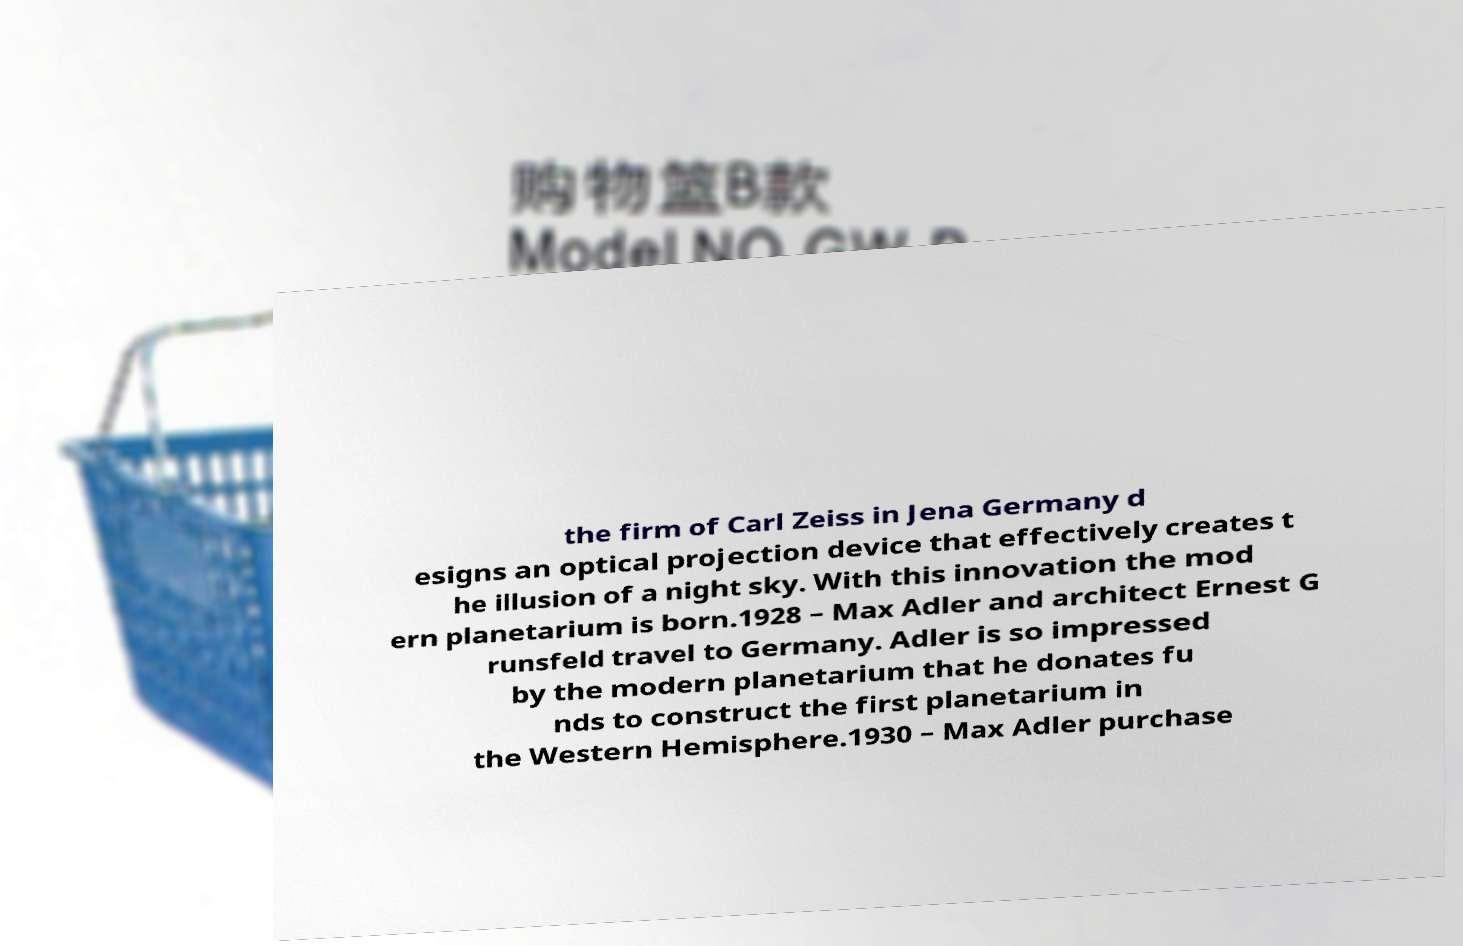Please identify and transcribe the text found in this image. the firm of Carl Zeiss in Jena Germany d esigns an optical projection device that effectively creates t he illusion of a night sky. With this innovation the mod ern planetarium is born.1928 – Max Adler and architect Ernest G runsfeld travel to Germany. Adler is so impressed by the modern planetarium that he donates fu nds to construct the first planetarium in the Western Hemisphere.1930 – Max Adler purchase 